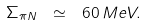Convert formula to latex. <formula><loc_0><loc_0><loc_500><loc_500>\Sigma _ { \pi N } \ \simeq \ 6 0 \, M e V .</formula> 